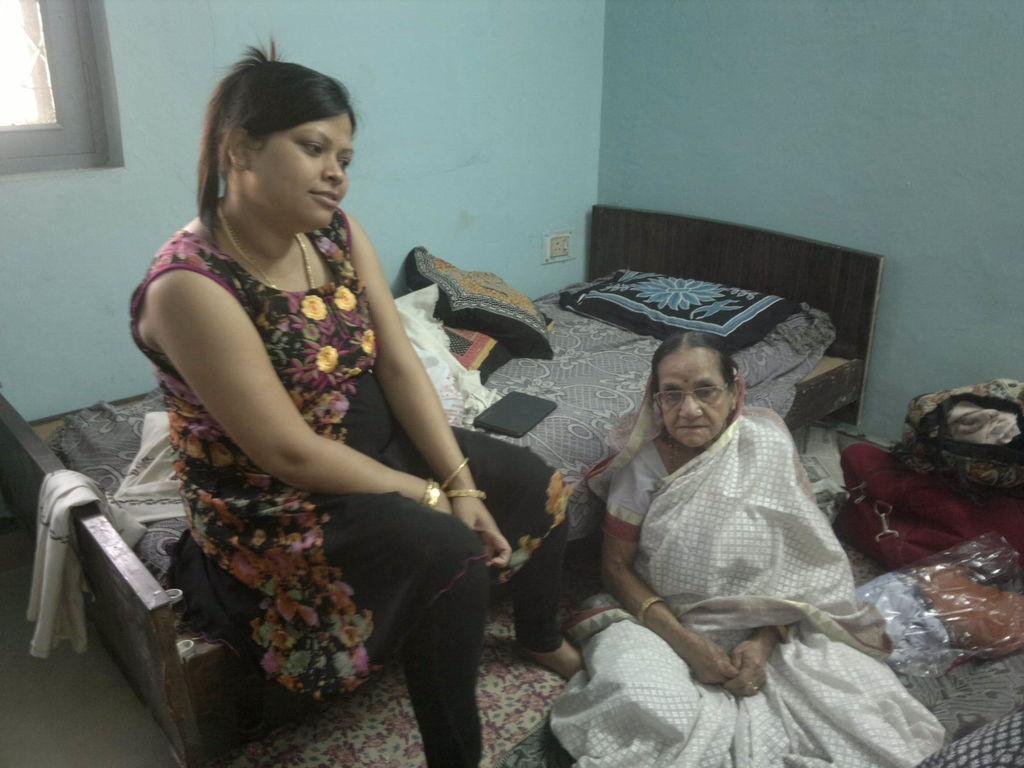Can you describe this image briefly? In this picture we can see a woman wearing a spectacle and sitting. There are a few bags and other objects are visible on the ground. We can see a person, pillows, white cloth and other objects on the bed. We can see a switch board on the wall. There is a window visible in the top left. 